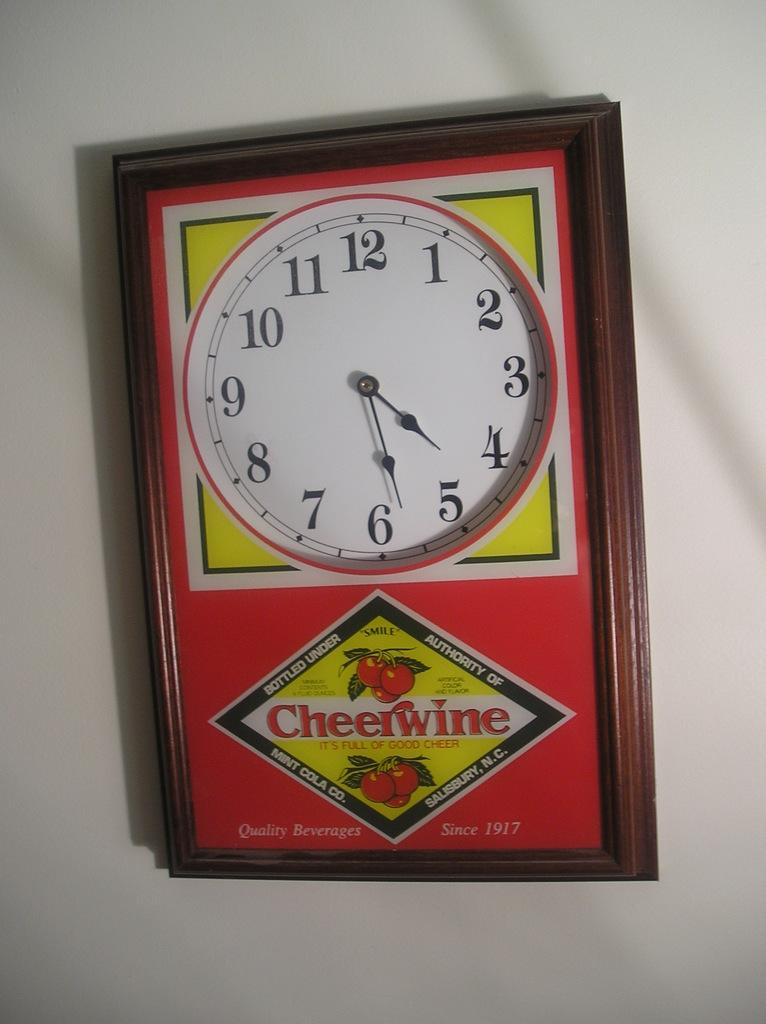Provide a one-sentence caption for the provided image. The clock is yellow and red and is from Cheerwine. 